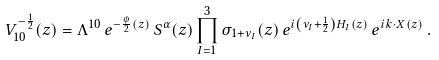Convert formula to latex. <formula><loc_0><loc_0><loc_500><loc_500>V ^ { - \frac { 1 } { 2 } } _ { 1 0 } ( z ) & = \Lambda ^ { 1 0 } \, e ^ { - \frac { \phi } { 2 } ( z ) } \, S ^ { \alpha } ( z ) \prod ^ { 3 } _ { I = 1 } \sigma _ { 1 + \nu _ { I } } ( z ) \, e ^ { i \left ( \nu _ { I } + \frac { 1 } { 2 } \right ) H _ { I } ( z ) } \, e ^ { i k \cdot X ( z ) } \, .</formula> 